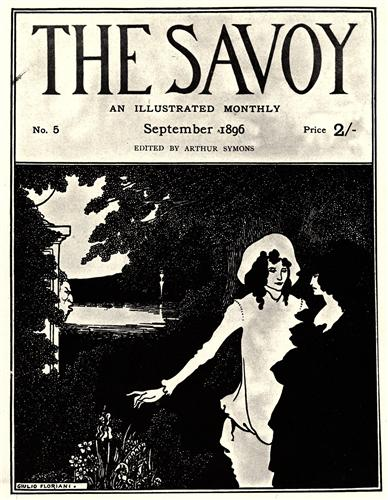Consider this image in a historical context. What does it tell us about the era it was created in? The image offers a window into the cultural and artistic sensibilities of the late 19th century, a period marked by a strong emphasis on aestheticism and the burgeoning Art Nouveau movement. It reflects the era's fascination with nature, elegance, and intricate design. The depiction of a serene garden and a romantically engaged couple indicates a society that valued beauty, tranquility, and introspective moments. Additionally, the presence of 'The Savoy' magazine signifies the period's literary and artistic pursuits, as it was a time when literature, art, and culture were flourishing. The mention of the price, 2 shillings, situates the image within the socio-economic context of the time, reminding us of the value placed on such artistic expressions. 